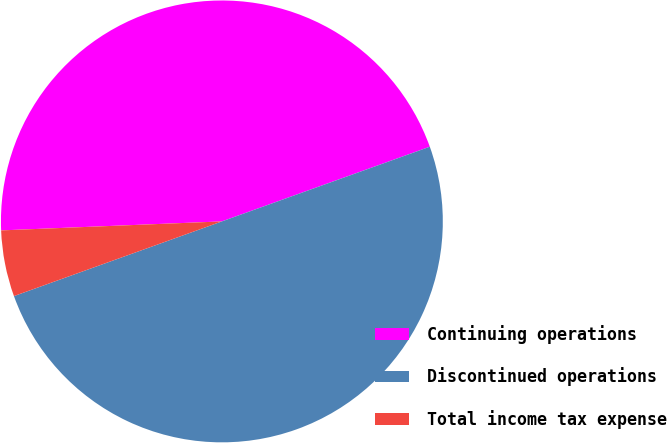Convert chart to OTSL. <chart><loc_0><loc_0><loc_500><loc_500><pie_chart><fcel>Continuing operations<fcel>Discontinued operations<fcel>Total income tax expense<nl><fcel>45.16%<fcel>50.0%<fcel>4.84%<nl></chart> 